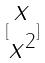Convert formula to latex. <formula><loc_0><loc_0><loc_500><loc_500>[ \begin{matrix} x \\ x ^ { 2 } \end{matrix} ]</formula> 